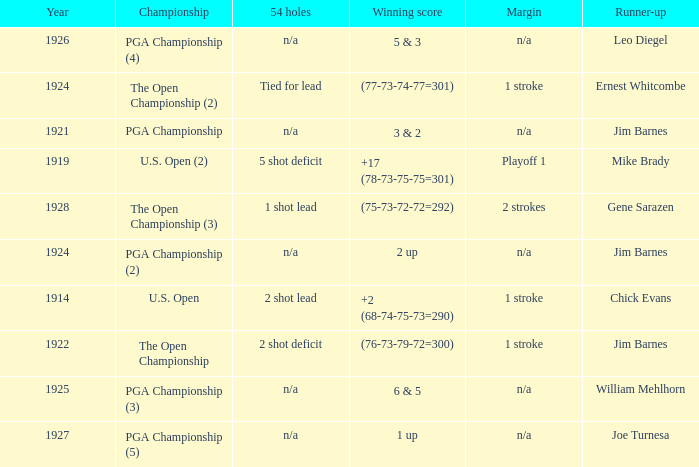What is the duration in years represented by the score (76-73-79-72=300)? 1.0. 